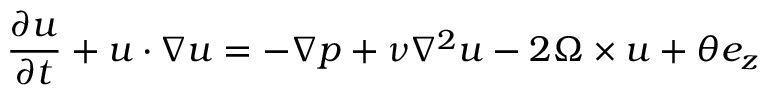Convert formula to latex. <formula><loc_0><loc_0><loc_500><loc_500>\frac { \partial u } { \partial t } + u \cdot \nabla u = - \nabla p + \nu \nabla ^ { 2 } u - 2 \Omega \times u + \theta e _ { z }</formula> 